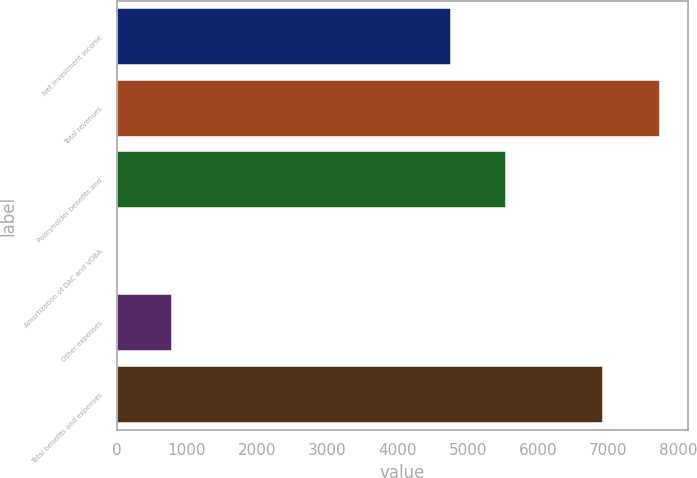<chart> <loc_0><loc_0><loc_500><loc_500><bar_chart><fcel>Net investment income<fcel>Total revenues<fcel>Policyholder benefits and<fcel>Amortization of DAC and VOBA<fcel>Other expenses<fcel>Total benefits and expenses<nl><fcel>4766<fcel>7742<fcel>5538.7<fcel>15<fcel>787.7<fcel>6918<nl></chart> 